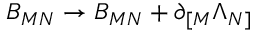Convert formula to latex. <formula><loc_0><loc_0><loc_500><loc_500>B _ { M N } \rightarrow B _ { M N } + \partial _ { [ M } \Lambda _ { N ] }</formula> 